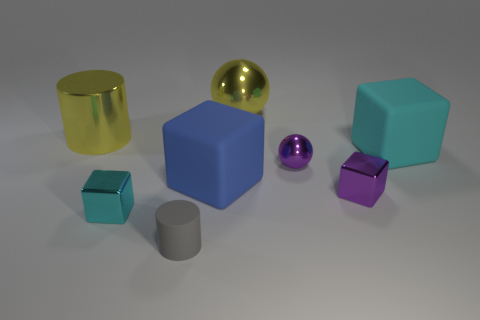Subtract 1 blocks. How many blocks are left? 3 Add 1 large cylinders. How many objects exist? 9 Subtract all cyan cylinders. Subtract all yellow blocks. How many cylinders are left? 2 Subtract all cylinders. How many objects are left? 6 Add 4 small red cubes. How many small red cubes exist? 4 Subtract 1 gray cylinders. How many objects are left? 7 Subtract all large metallic cylinders. Subtract all red rubber cubes. How many objects are left? 7 Add 2 big cyan blocks. How many big cyan blocks are left? 3 